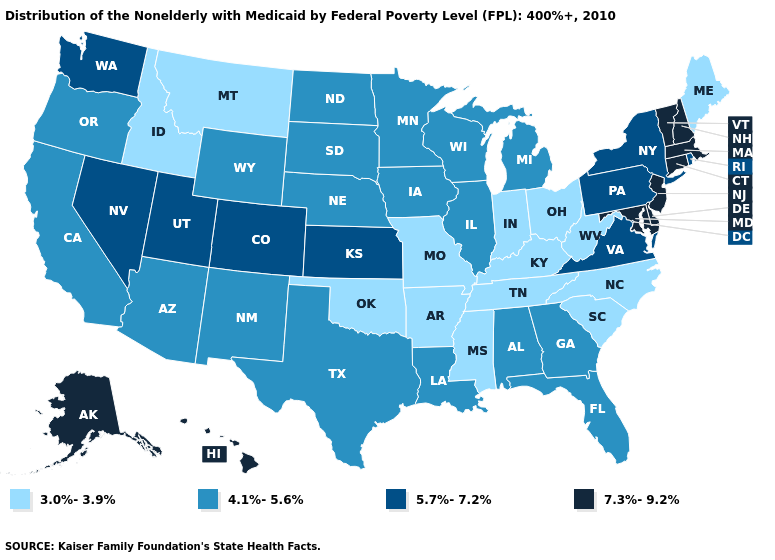What is the highest value in the USA?
Write a very short answer. 7.3%-9.2%. What is the value of New Mexico?
Short answer required. 4.1%-5.6%. Does North Carolina have a lower value than Idaho?
Write a very short answer. No. What is the value of Georgia?
Keep it brief. 4.1%-5.6%. Among the states that border Connecticut , does New York have the lowest value?
Concise answer only. Yes. Is the legend a continuous bar?
Keep it brief. No. What is the highest value in the USA?
Quick response, please. 7.3%-9.2%. What is the value of Maine?
Quick response, please. 3.0%-3.9%. Which states have the lowest value in the USA?
Answer briefly. Arkansas, Idaho, Indiana, Kentucky, Maine, Mississippi, Missouri, Montana, North Carolina, Ohio, Oklahoma, South Carolina, Tennessee, West Virginia. What is the value of Utah?
Concise answer only. 5.7%-7.2%. Name the states that have a value in the range 3.0%-3.9%?
Concise answer only. Arkansas, Idaho, Indiana, Kentucky, Maine, Mississippi, Missouri, Montana, North Carolina, Ohio, Oklahoma, South Carolina, Tennessee, West Virginia. What is the highest value in the South ?
Give a very brief answer. 7.3%-9.2%. What is the lowest value in the USA?
Short answer required. 3.0%-3.9%. What is the lowest value in the MidWest?
Write a very short answer. 3.0%-3.9%. How many symbols are there in the legend?
Keep it brief. 4. 